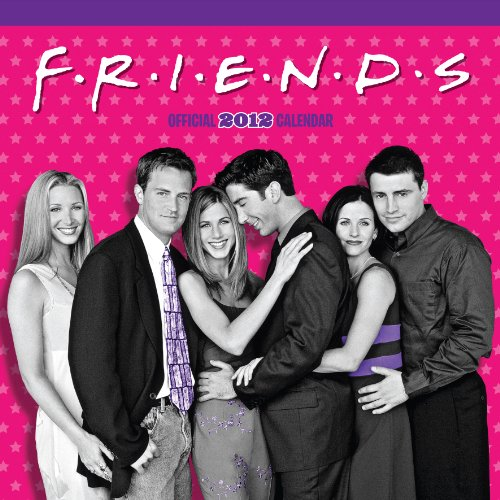What are some special dates that might be marked in this 'Friends' themed calendar? This calendar might include birthdays of main characters, anniversaries of significant episodes, and perhaps fun fictitious events like 'Ross's Unagi Day' or 'Central Perk Day.' Each date would likely be accompanied by a relevant image or quote from the show. 